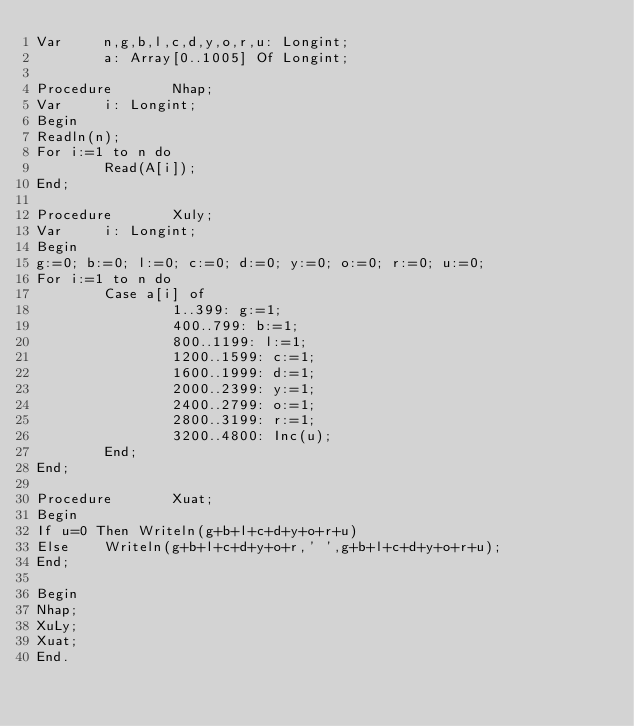<code> <loc_0><loc_0><loc_500><loc_500><_Pascal_>Var     n,g,b,l,c,d,y,o,r,u: Longint;
        a: Array[0..1005] Of Longint;

Procedure       Nhap;
Var     i: Longint;
Begin
Readln(n);
For i:=1 to n do
        Read(A[i]);
End;

Procedure       Xuly;
Var     i: Longint;
Begin
g:=0; b:=0; l:=0; c:=0; d:=0; y:=0; o:=0; r:=0; u:=0;
For i:=1 to n do
        Case a[i] of
                1..399: g:=1;
                400..799: b:=1;
                800..1199: l:=1;
                1200..1599: c:=1;
                1600..1999: d:=1;
                2000..2399: y:=1;
                2400..2799: o:=1;
                2800..3199: r:=1;
                3200..4800: Inc(u);
        End;
End;

Procedure       Xuat;
Begin
If u=0 Then Writeln(g+b+l+c+d+y+o+r+u)
Else    Writeln(g+b+l+c+d+y+o+r,' ',g+b+l+c+d+y+o+r+u);
End;

Begin
Nhap;
XuLy;
Xuat;
End.</code> 